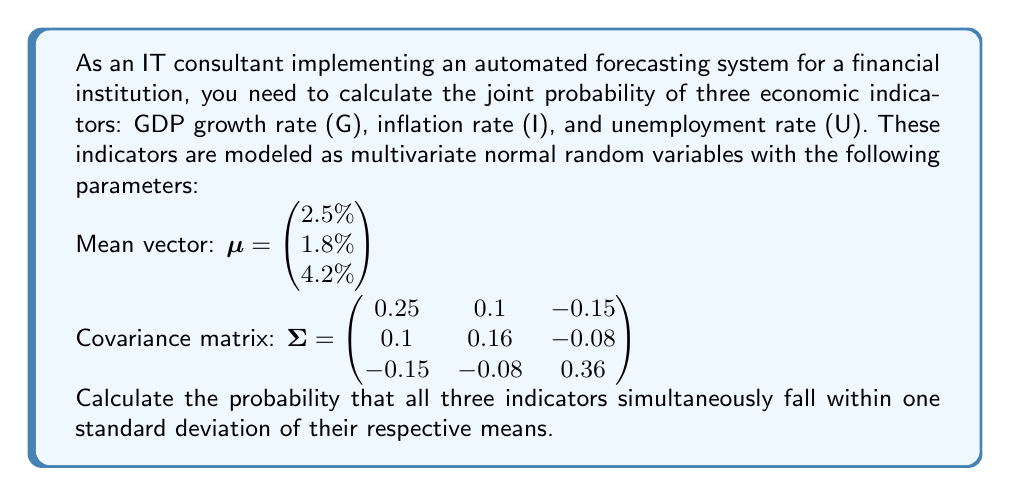Show me your answer to this math problem. To solve this problem, we'll follow these steps:

1) For a multivariate normal distribution, the probability that all variables fall within one standard deviation of their means is given by the integral of the probability density function over a rectangular region centered at the mean, with sides of length 2 standard deviations.

2) In three dimensions, this probability is:

   $$P(|\mathbf{X} - \mu| \leq \sigma) = \int_{-1}^1 \int_{-1}^1 \int_{-1}^1 f_{\mathbf{X}}(x,y,z) dx dy dz$$

   where $f_{\mathbf{X}}(x,y,z)$ is the probability density function of the multivariate normal distribution.

3) For a general n-dimensional multivariate normal distribution, this probability is equal to:

   $$P(|\mathbf{X} - \mu| \leq \sigma) = \Phi_n(\mathbf{1}, \mathbf{0}, \mathbf{R})$$

   where $\Phi_n$ is the n-dimensional standard normal cumulative distribution function, $\mathbf{1}$ is a vector of ones, $\mathbf{0}$ is a vector of zeros, and $\mathbf{R}$ is the correlation matrix.

4) The correlation matrix $\mathbf{R}$ can be derived from the covariance matrix $\Sigma$ as follows:

   $$R_{ij} = \frac{\Sigma_{ij}}{\sqrt{\Sigma_{ii}\Sigma_{jj}}}$$

5) Calculating the correlation matrix:

   $$\mathbf{R} = \begin{pmatrix} 
   1 & 0.5 & -0.5 \\
   0.5 & 1 & -0.3333 \\
   -0.5 & -0.3333 & 1
   \end{pmatrix}$$

6) The probability we're looking for is $\Phi_3(\mathbf{1}, \mathbf{0}, \mathbf{R})$.

7) This integral doesn't have a closed-form solution and is typically evaluated numerically. Using statistical software or numerical integration methods, we can calculate this probability.

8) The result of this calculation is approximately 0.4986 or 49.86%.
Answer: 0.4986 